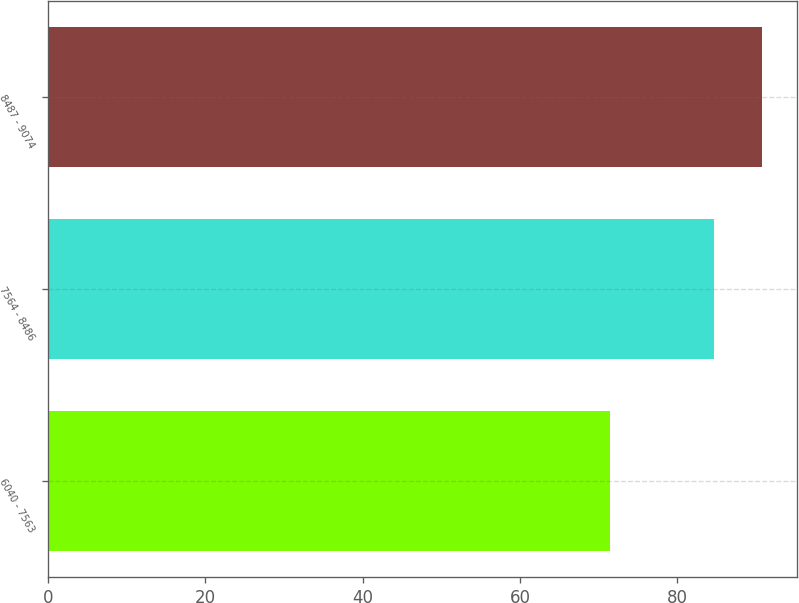Convert chart. <chart><loc_0><loc_0><loc_500><loc_500><bar_chart><fcel>6040 - 7563<fcel>7564 - 8486<fcel>8487 - 9074<nl><fcel>71.45<fcel>84.62<fcel>90.74<nl></chart> 